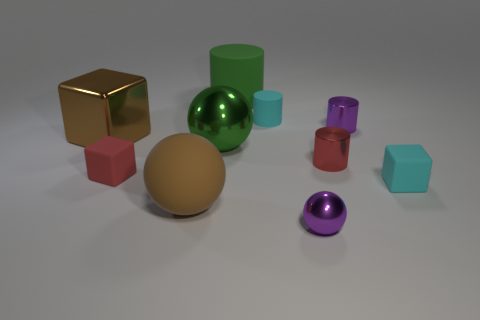Subtract all blocks. How many objects are left? 7 Subtract all small yellow metal things. Subtract all big spheres. How many objects are left? 8 Add 7 large blocks. How many large blocks are left? 8 Add 1 tiny green rubber objects. How many tiny green rubber objects exist? 1 Subtract 0 yellow blocks. How many objects are left? 10 